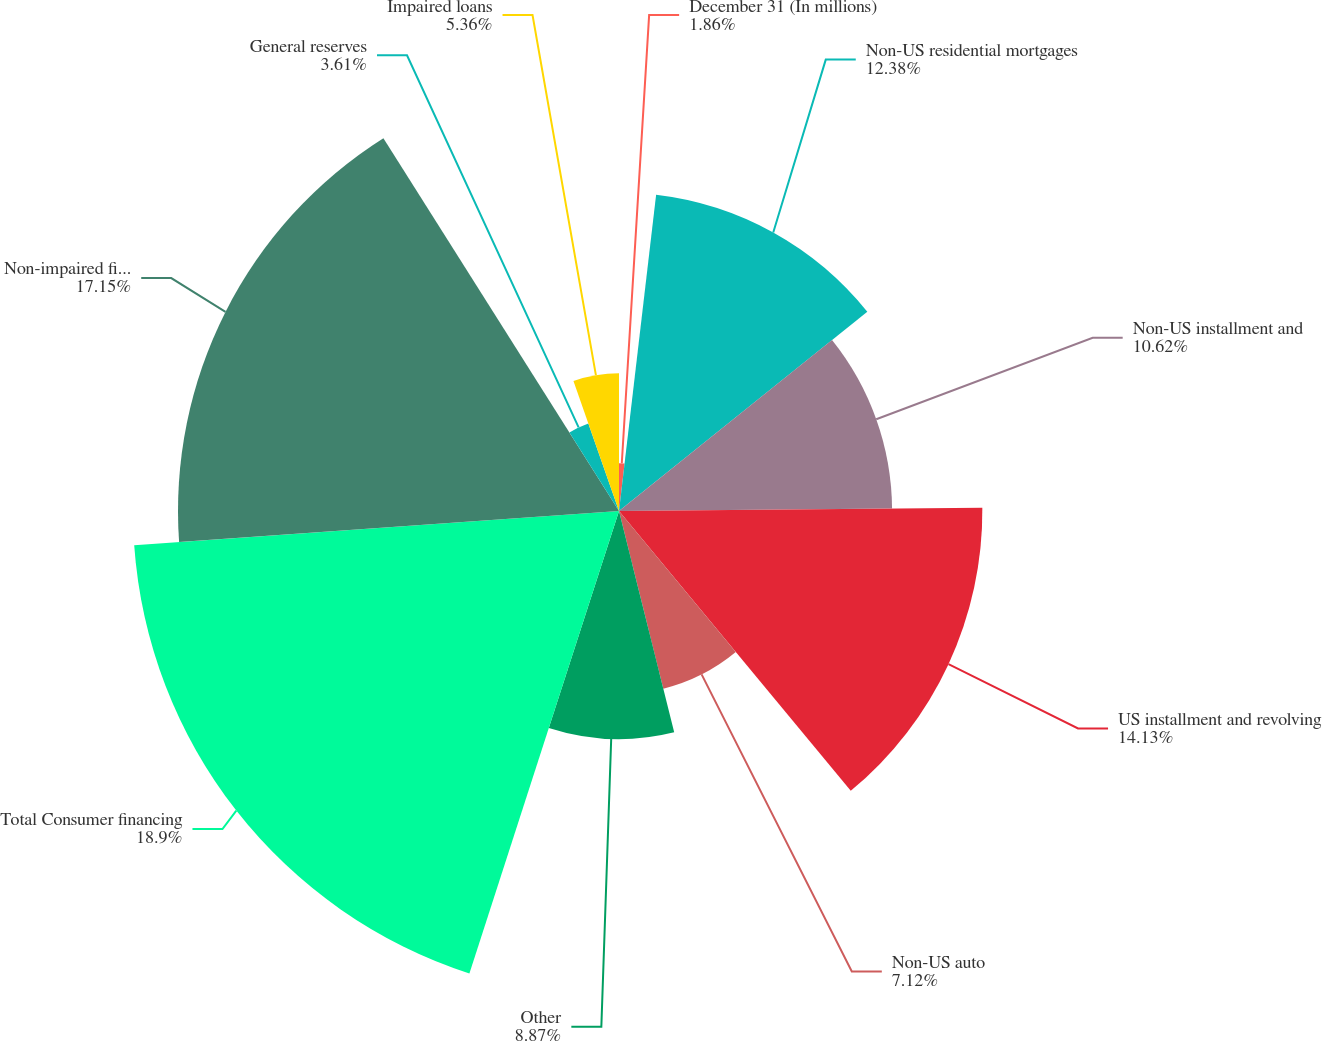Convert chart. <chart><loc_0><loc_0><loc_500><loc_500><pie_chart><fcel>December 31 (In millions)<fcel>Non-US residential mortgages<fcel>Non-US installment and<fcel>US installment and revolving<fcel>Non-US auto<fcel>Other<fcel>Total Consumer financing<fcel>Non-impaired financing<fcel>General reserves<fcel>Impaired loans<nl><fcel>1.86%<fcel>12.38%<fcel>10.62%<fcel>14.13%<fcel>7.12%<fcel>8.87%<fcel>18.9%<fcel>17.15%<fcel>3.61%<fcel>5.36%<nl></chart> 